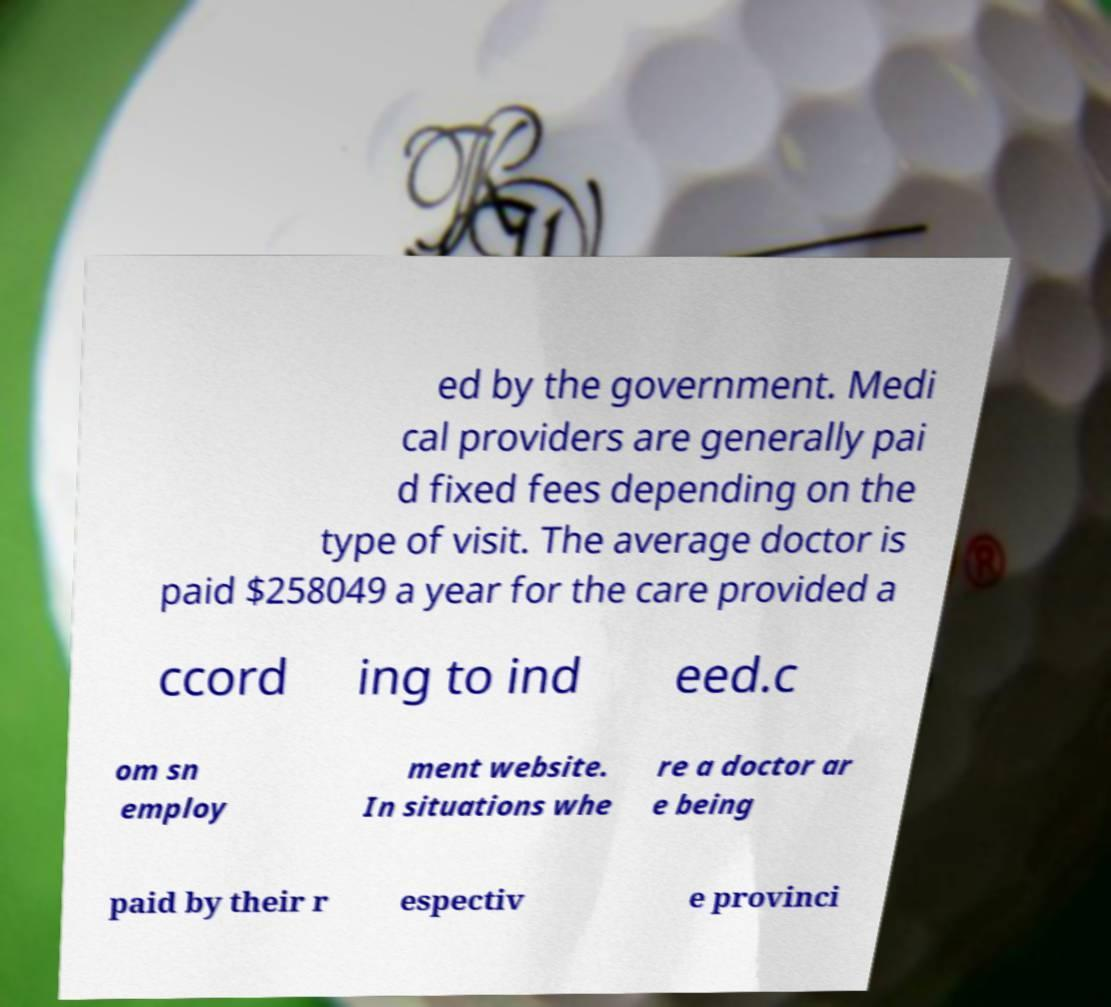Could you assist in decoding the text presented in this image and type it out clearly? ed by the government. Medi cal providers are generally pai d fixed fees depending on the type of visit. The average doctor is paid $258049 a year for the care provided a ccord ing to ind eed.c om sn employ ment website. In situations whe re a doctor ar e being paid by their r espectiv e provinci 